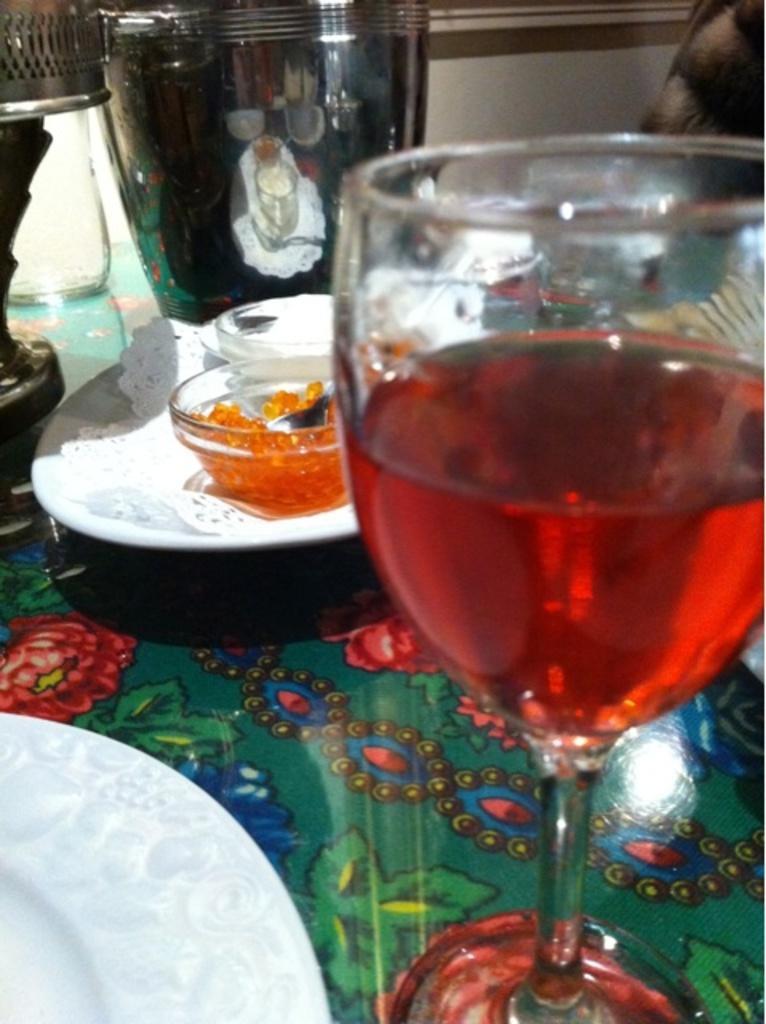Can you describe this image briefly? In this image, we can see a wine glass with liquid, plates and few objects are on the surface. Background there is a wall. Here there is a steel object. On this object, we can see some reflections. 